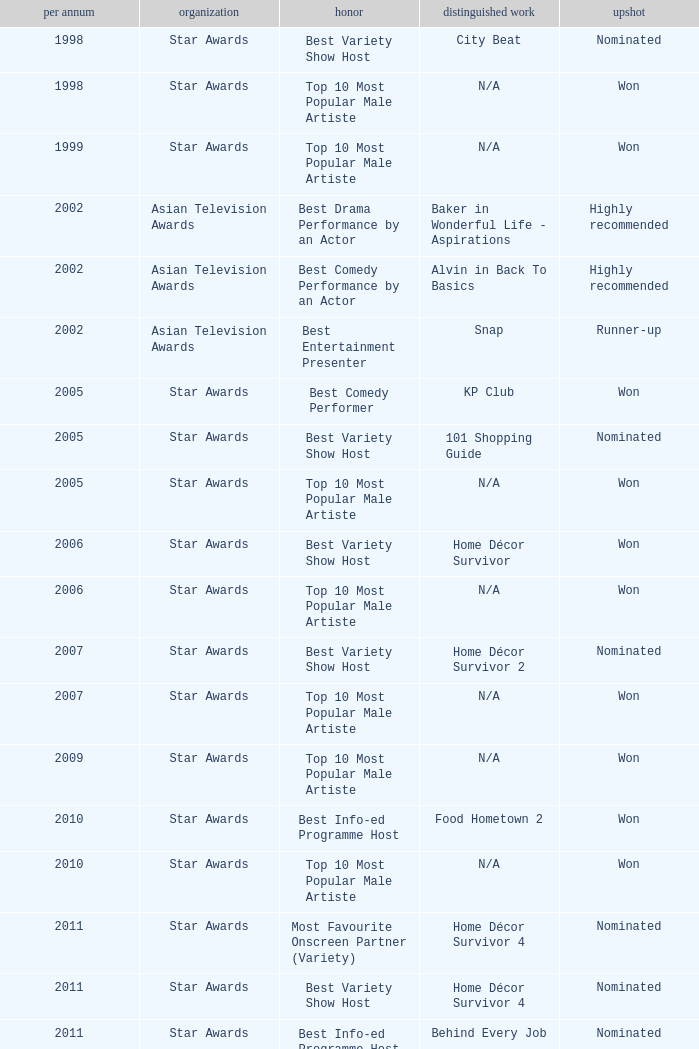What is the organisation in 2011 that was nominated and the award of best info-ed programme host? Star Awards. 